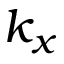Convert formula to latex. <formula><loc_0><loc_0><loc_500><loc_500>k _ { x }</formula> 